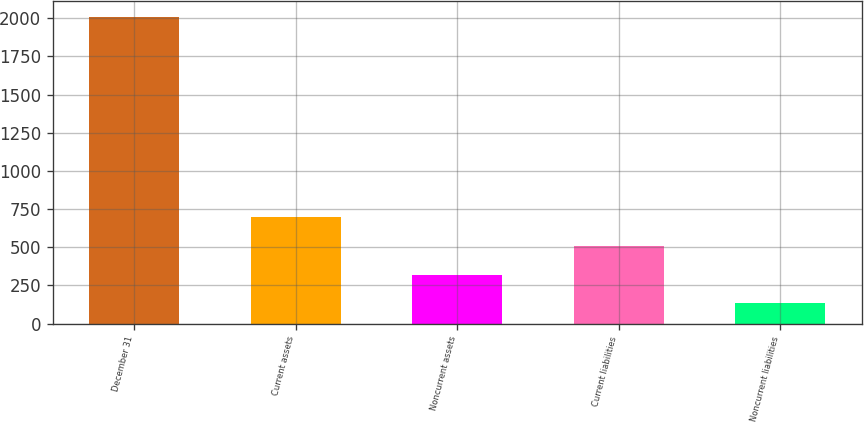Convert chart. <chart><loc_0><loc_0><loc_500><loc_500><bar_chart><fcel>December 31<fcel>Current assets<fcel>Noncurrent assets<fcel>Current liabilities<fcel>Noncurrent liabilities<nl><fcel>2010<fcel>699<fcel>320.7<fcel>508.4<fcel>133<nl></chart> 